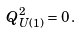<formula> <loc_0><loc_0><loc_500><loc_500>Q _ { U ( 1 ) } ^ { 2 } = 0 \, .</formula> 